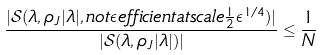<formula> <loc_0><loc_0><loc_500><loc_500>\frac { | \mathcal { S } ( \lambda , \rho _ { J } | \lambda | , n o t \epsilon e f f i c i e n t a t s c a l e \frac { 1 } { 2 } \epsilon ^ { 1 / 4 } ) | } { | \mathcal { S } ( \lambda , \rho _ { J } | \lambda | ) | } \leq \frac { 1 } { N }</formula> 